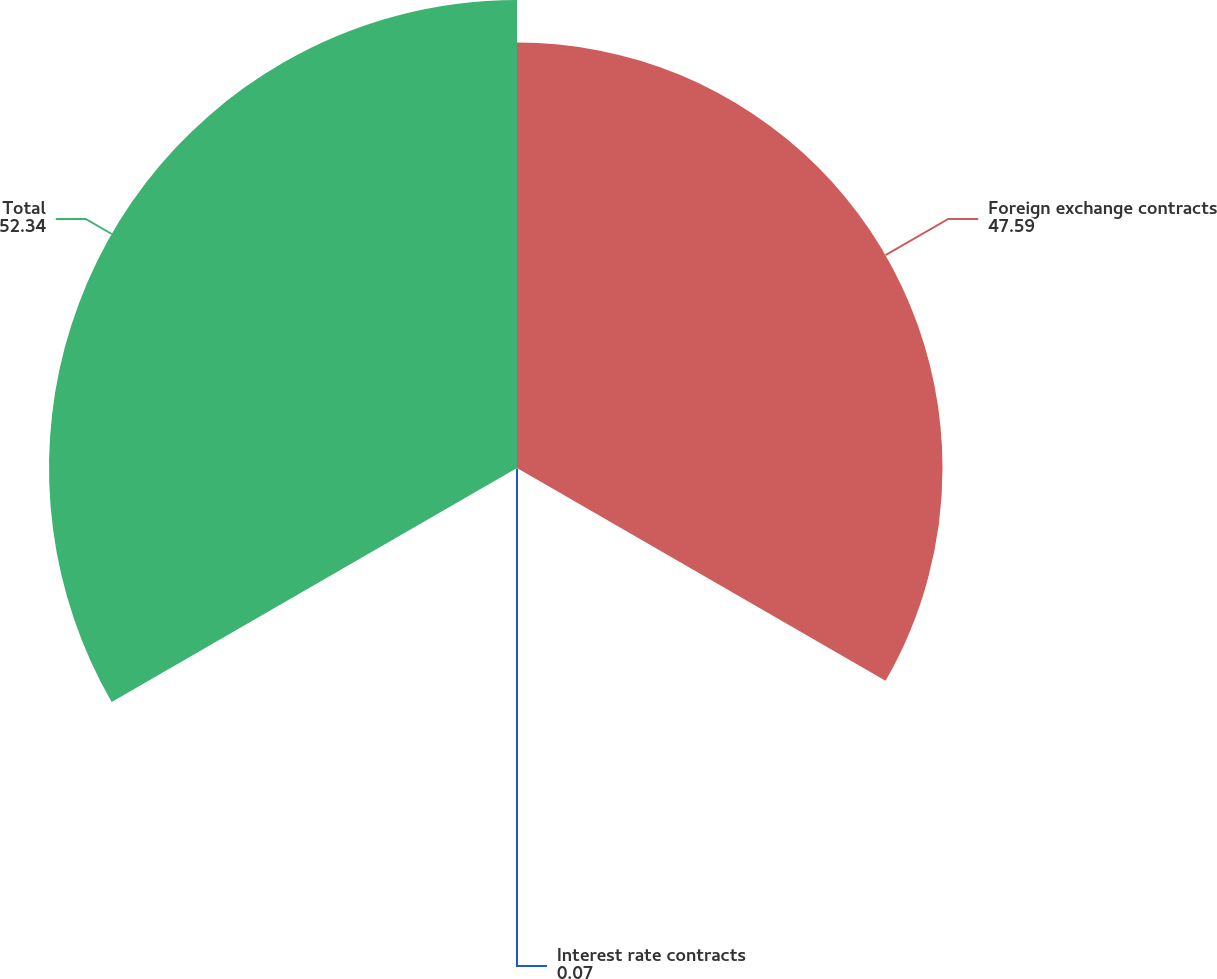<chart> <loc_0><loc_0><loc_500><loc_500><pie_chart><fcel>Foreign exchange contracts<fcel>Interest rate contracts<fcel>Total<nl><fcel>47.59%<fcel>0.07%<fcel>52.34%<nl></chart> 